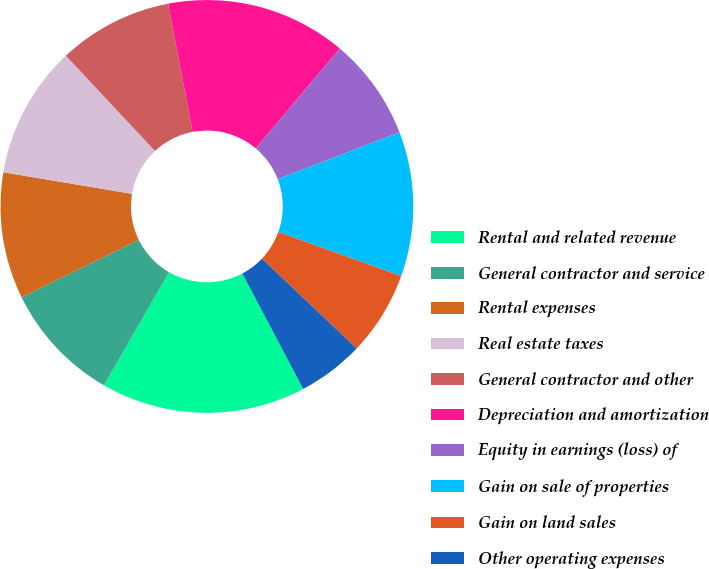Convert chart. <chart><loc_0><loc_0><loc_500><loc_500><pie_chart><fcel>Rental and related revenue<fcel>General contractor and service<fcel>Rental expenses<fcel>Real estate taxes<fcel>General contractor and other<fcel>Depreciation and amortization<fcel>Equity in earnings (loss) of<fcel>Gain on sale of properties<fcel>Gain on land sales<fcel>Other operating expenses<nl><fcel>16.04%<fcel>9.43%<fcel>9.91%<fcel>10.38%<fcel>8.96%<fcel>14.15%<fcel>8.02%<fcel>11.32%<fcel>6.6%<fcel>5.19%<nl></chart> 